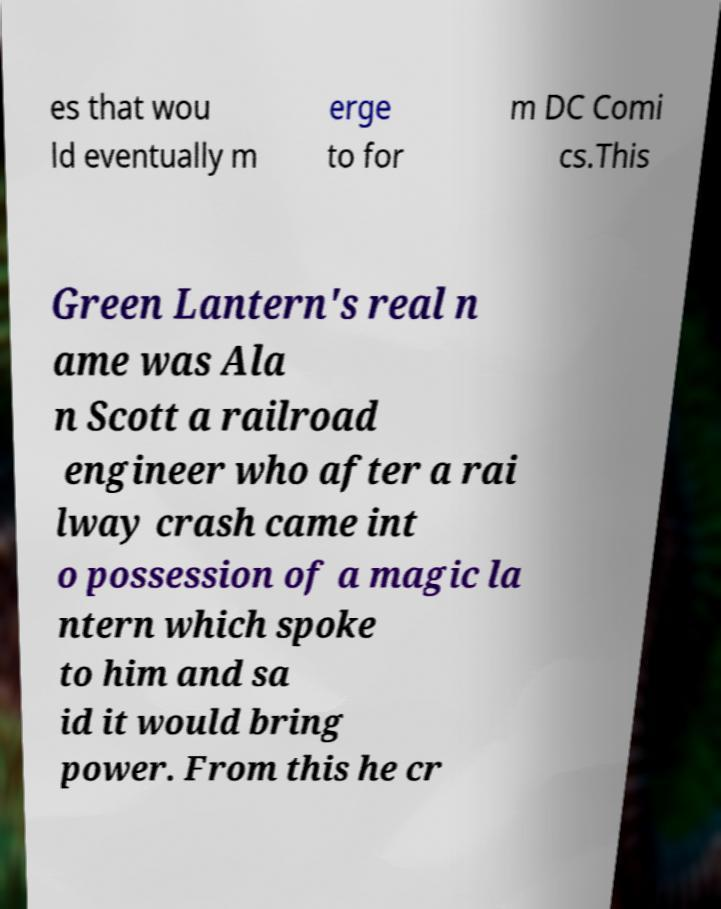I need the written content from this picture converted into text. Can you do that? es that wou ld eventually m erge to for m DC Comi cs.This Green Lantern's real n ame was Ala n Scott a railroad engineer who after a rai lway crash came int o possession of a magic la ntern which spoke to him and sa id it would bring power. From this he cr 